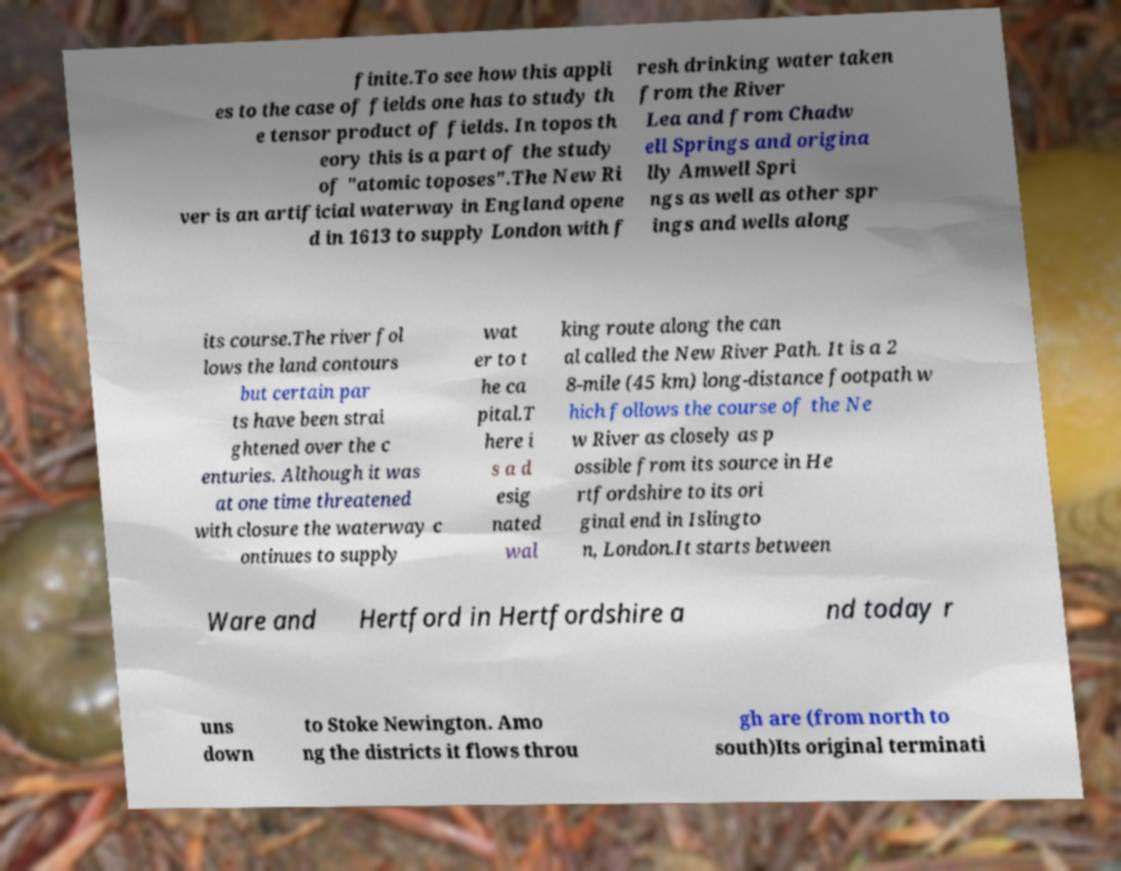Please read and relay the text visible in this image. What does it say? finite.To see how this appli es to the case of fields one has to study th e tensor product of fields. In topos th eory this is a part of the study of "atomic toposes".The New Ri ver is an artificial waterway in England opene d in 1613 to supply London with f resh drinking water taken from the River Lea and from Chadw ell Springs and origina lly Amwell Spri ngs as well as other spr ings and wells along its course.The river fol lows the land contours but certain par ts have been strai ghtened over the c enturies. Although it was at one time threatened with closure the waterway c ontinues to supply wat er to t he ca pital.T here i s a d esig nated wal king route along the can al called the New River Path. It is a 2 8-mile (45 km) long-distance footpath w hich follows the course of the Ne w River as closely as p ossible from its source in He rtfordshire to its ori ginal end in Islingto n, London.It starts between Ware and Hertford in Hertfordshire a nd today r uns down to Stoke Newington. Amo ng the districts it flows throu gh are (from north to south)Its original terminati 